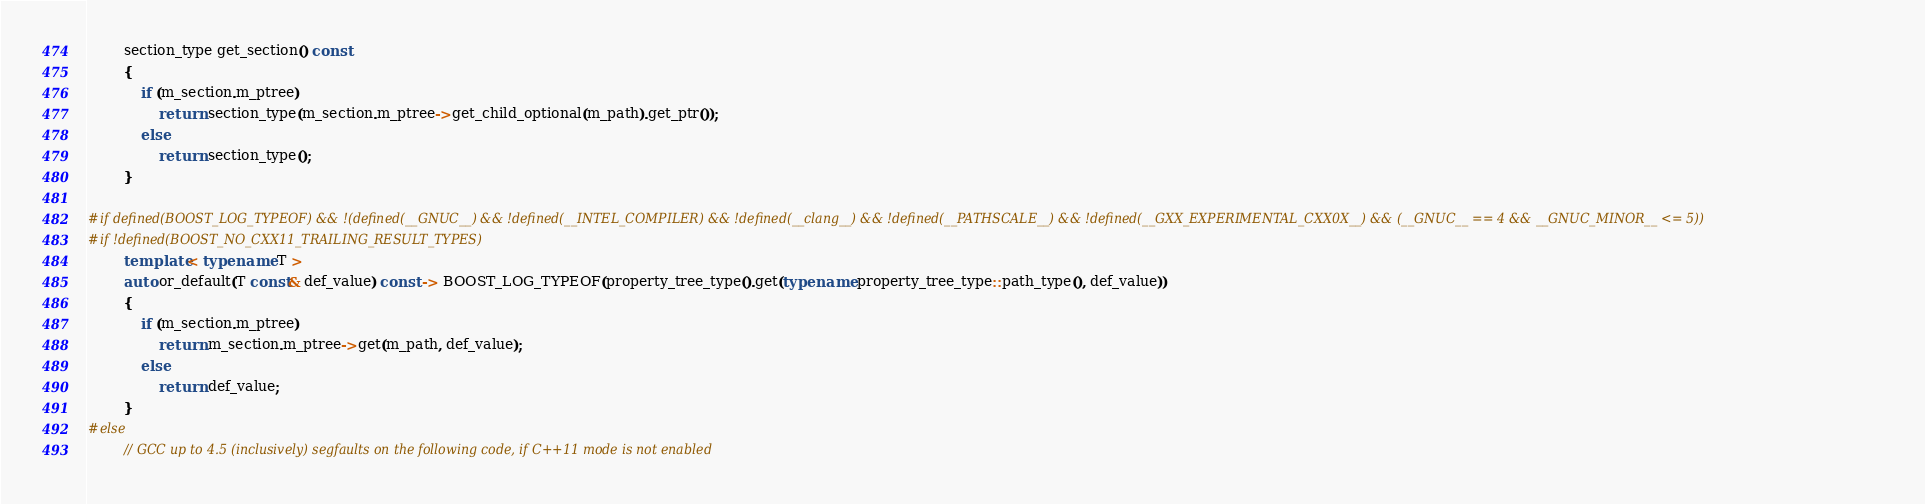Convert code to text. <code><loc_0><loc_0><loc_500><loc_500><_C++_>
        section_type get_section() const
        {
            if (m_section.m_ptree)
                return section_type(m_section.m_ptree->get_child_optional(m_path).get_ptr());
            else
                return section_type();
        }

#if defined(BOOST_LOG_TYPEOF) && !(defined(__GNUC__) && !defined(__INTEL_COMPILER) && !defined(__clang__) && !defined(__PATHSCALE__) && !defined(__GXX_EXPERIMENTAL_CXX0X__) && (__GNUC__ == 4 && __GNUC_MINOR__ <= 5))
#if !defined(BOOST_NO_CXX11_TRAILING_RESULT_TYPES)
        template< typename T >
        auto or_default(T const& def_value) const -> BOOST_LOG_TYPEOF(property_tree_type().get(typename property_tree_type::path_type(), def_value))
        {
            if (m_section.m_ptree)
                return m_section.m_ptree->get(m_path, def_value);
            else
                return def_value;
        }
#else
        // GCC up to 4.5 (inclusively) segfaults on the following code, if C++11 mode is not enabled</code> 